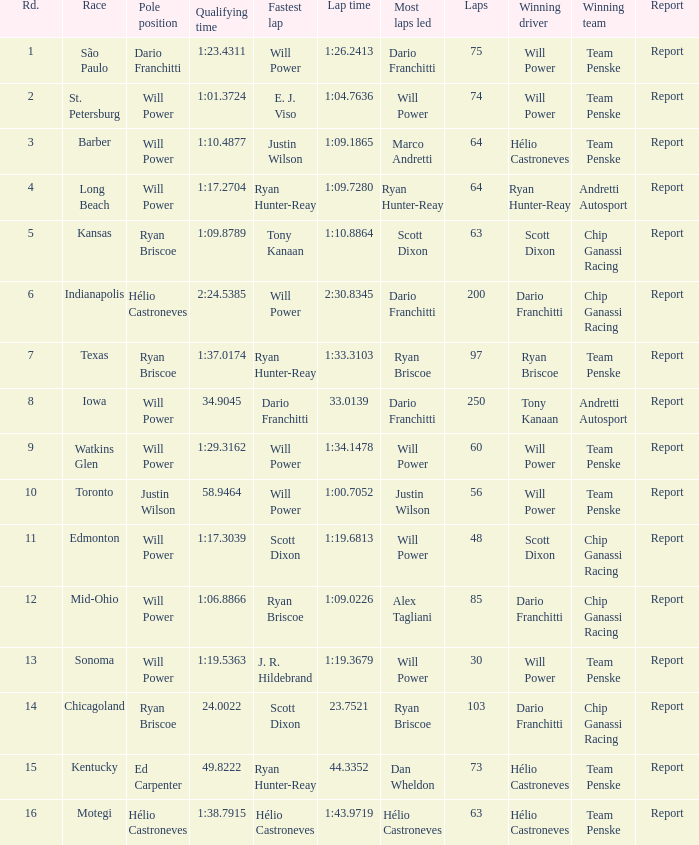In what position did the winning driver finish at Chicagoland? 1.0. 